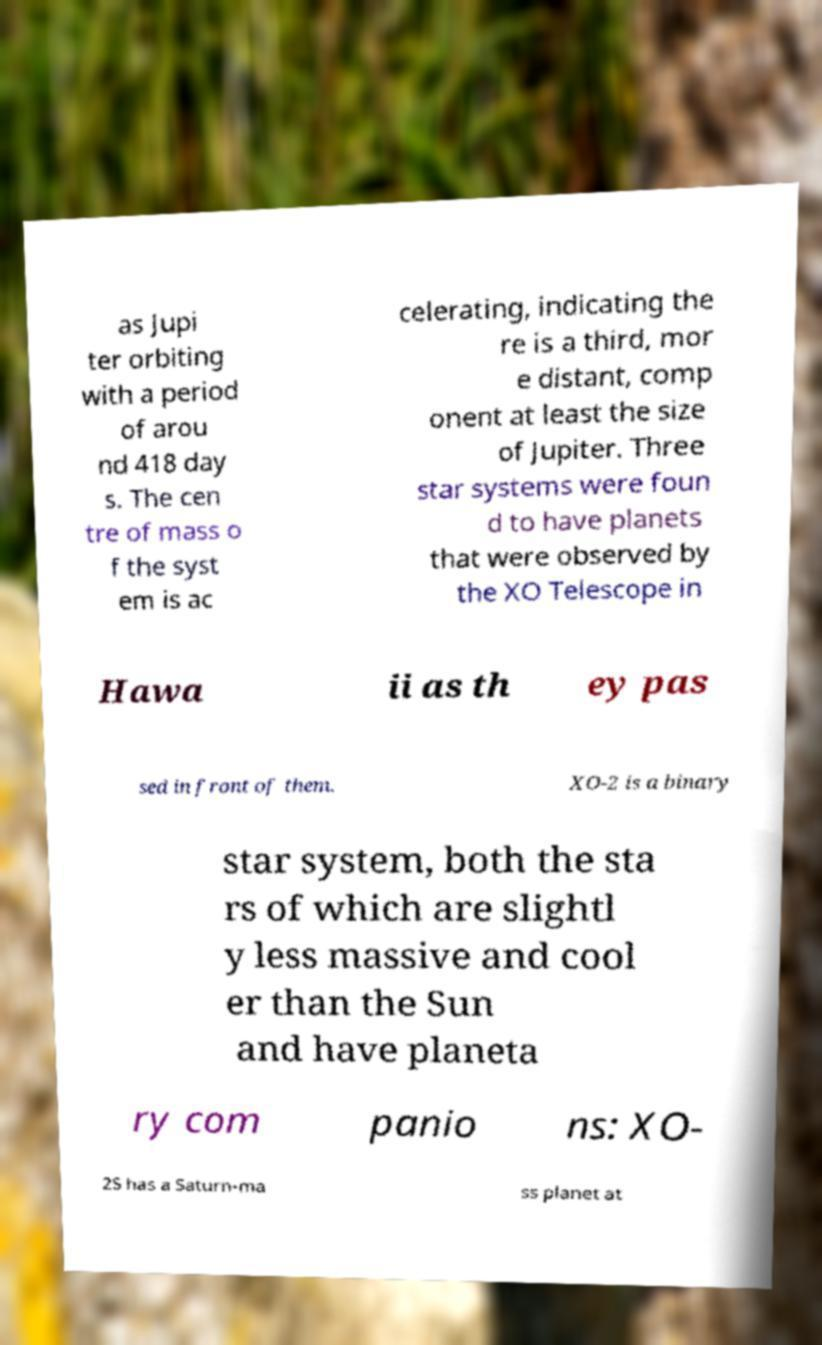Please identify and transcribe the text found in this image. as Jupi ter orbiting with a period of arou nd 418 day s. The cen tre of mass o f the syst em is ac celerating, indicating the re is a third, mor e distant, comp onent at least the size of Jupiter. Three star systems were foun d to have planets that were observed by the XO Telescope in Hawa ii as th ey pas sed in front of them. XO-2 is a binary star system, both the sta rs of which are slightl y less massive and cool er than the Sun and have planeta ry com panio ns: XO- 2S has a Saturn-ma ss planet at 